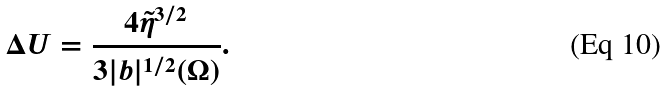Convert formula to latex. <formula><loc_0><loc_0><loc_500><loc_500>\Delta U = \frac { 4 \tilde { \eta } ^ { 3 / 2 } } { 3 | b | ^ { 1 / 2 } ( \Omega ) } .</formula> 